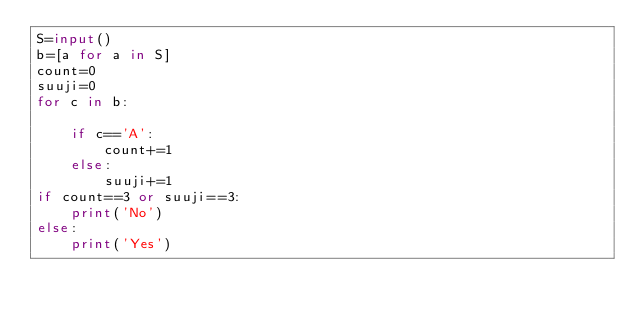<code> <loc_0><loc_0><loc_500><loc_500><_Python_>S=input()
b=[a for a in S]
count=0
suuji=0
for c in b:

    if c=='A':
        count+=1
    else:
        suuji+=1
if count==3 or suuji==3:
    print('No')
else:
    print('Yes')
    </code> 